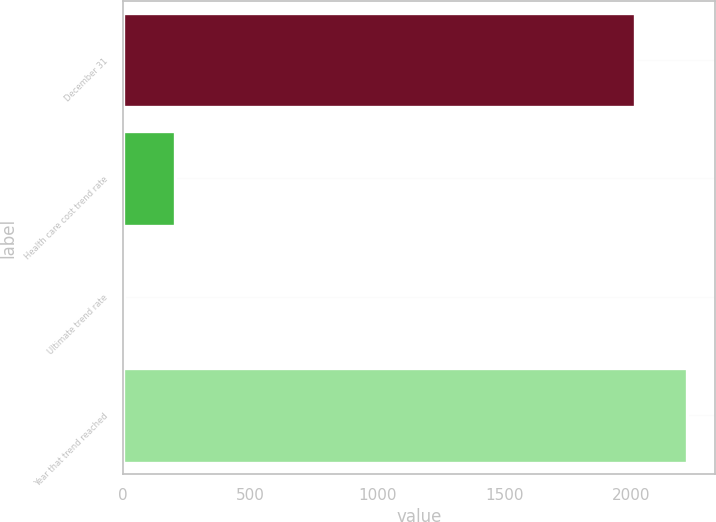<chart> <loc_0><loc_0><loc_500><loc_500><bar_chart><fcel>December 31<fcel>Health care cost trend rate<fcel>Ultimate trend rate<fcel>Year that trend reached<nl><fcel>2015<fcel>206.6<fcel>5<fcel>2216.6<nl></chart> 